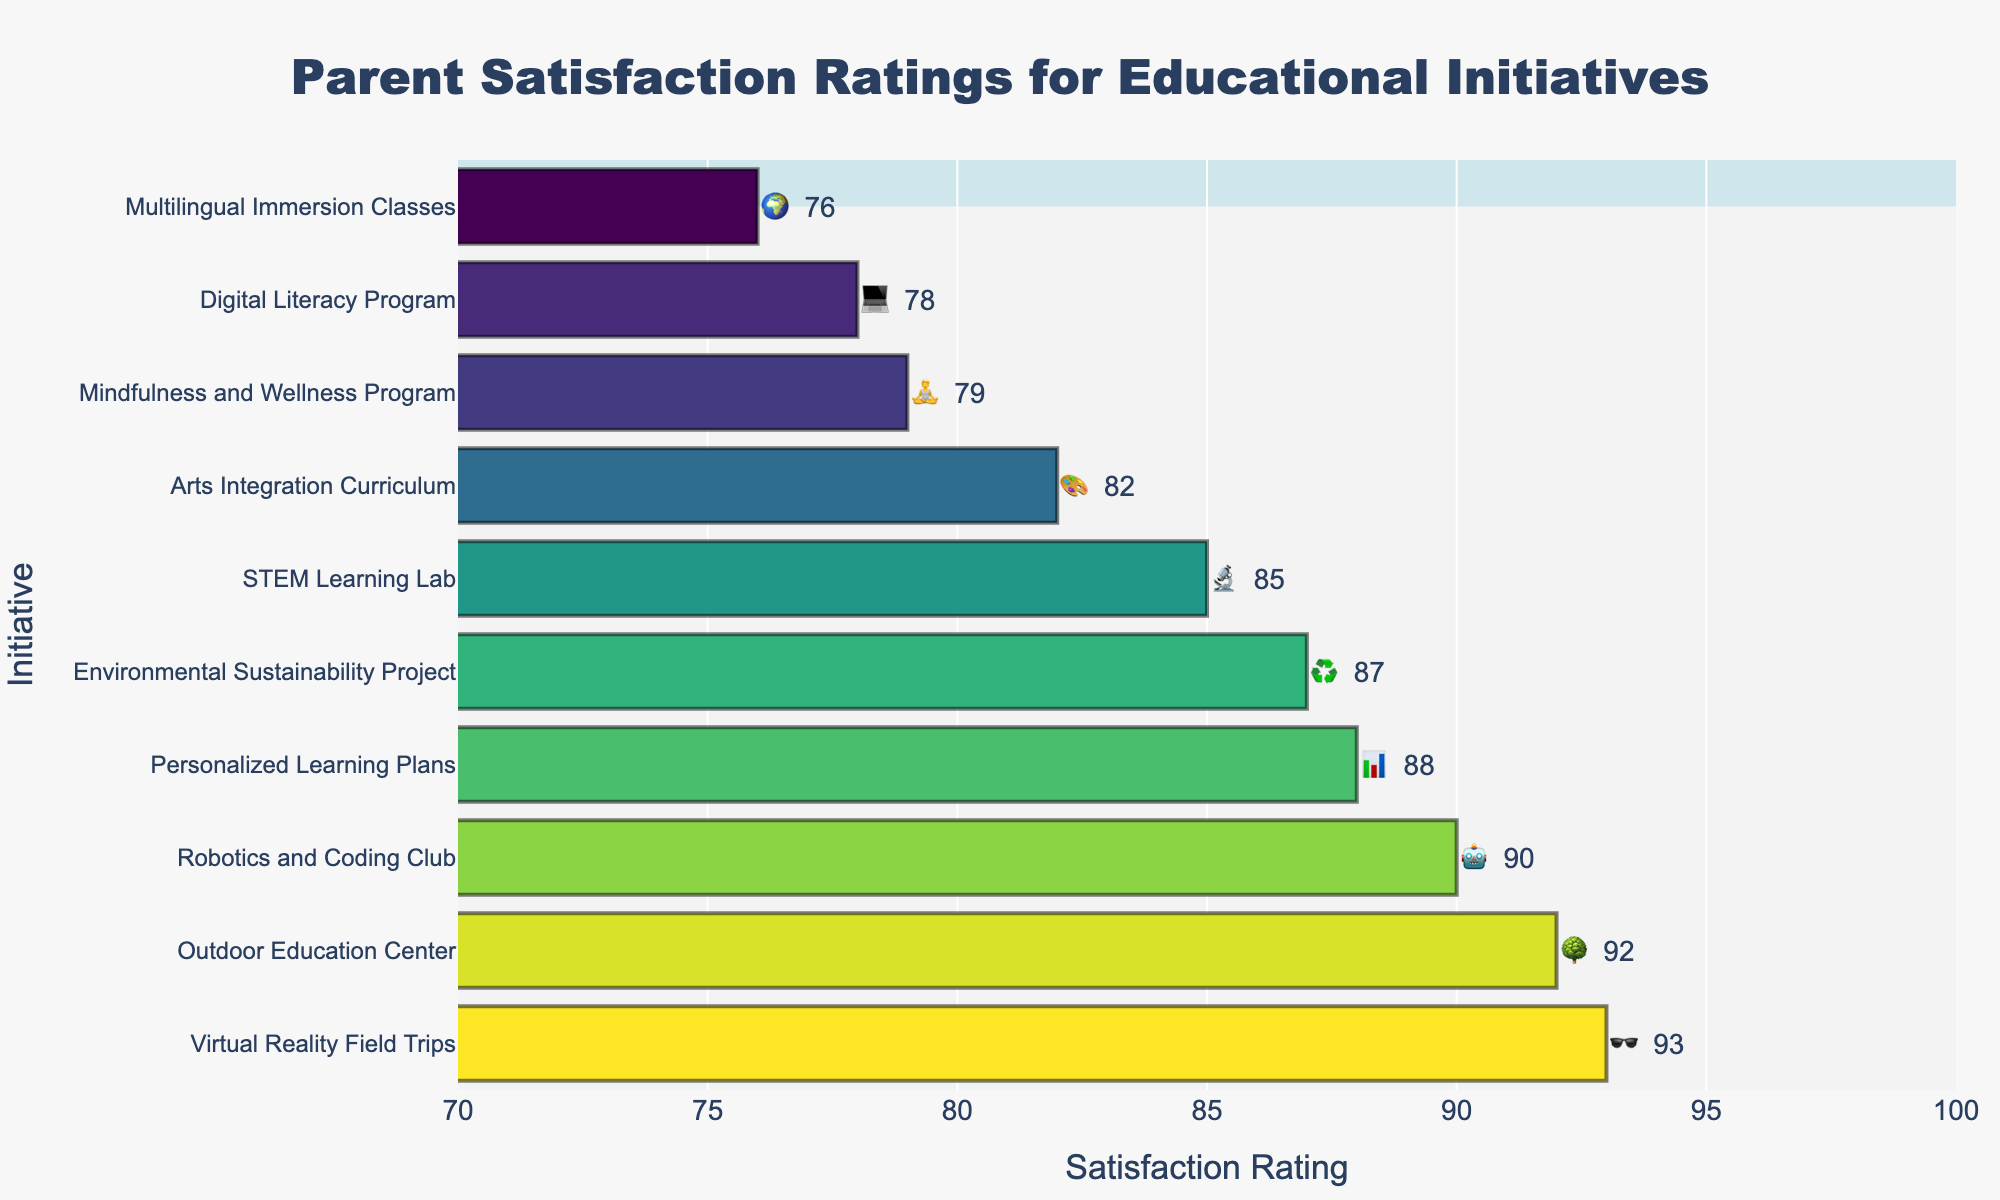What's the highest parent satisfaction rating among the initiatives? The Outdoor Education Center has a rating of 92, which is the highest among all initiatives.
Answer: 92 Which initiative has the lowest parent satisfaction rating? The Multilingual Immersion Classes have the lowest parent satisfaction rating with a score of 76.
Answer: The Multilingual Immersion Classes What is the satisfaction rating for the Virtual Reality Field Trips initiative? The Virtual Reality Field Trips initiative has a satisfaction rating of 93 according to the figure.
Answer: 93 How many initiatives have a satisfaction rating above 80? To find this, count the initiatives listed in the figure with ratings over 80. These initiatives are STEM Learning Lab, Outdoor Education Center, Personalized Learning Plans, Arts Integration Curriculum, Robotics and Coding Club, Environmental Sustainability Project, and Virtual Reality Field Trips. There are 7 such initiatives.
Answer: 7 Which initiative is represented by the emoji 🧘? The Mindfulness and Wellness Program is represented by the emoji 🧘 in the figure.
Answer: The Mindfulness and Wellness Program What is the difference in satisfaction ratings between the highest and lowest rated initiatives? The highest-rated initiative is the Virtual Reality Field Trips with a rating of 93, and the lowest rated is the Multilingual Immersion Classes with a rating of 76. The difference is 93 - 76 = 17.
Answer: 17 Between the Digital Literacy Program and the Arts Integration Curriculum, which has a higher satisfaction rating? The Arts Integration Curriculum has a satisfaction rating of 82, while the Digital Literacy Program has a rating of 78. Therefore, the Arts Integration Curriculum has a higher rating.
Answer: The Arts Integration Curriculum What percentage of initiatives have a satisfaction rating of 85 or higher? First, count the total number of initiatives, which is 10. Then count the initiatives with ratings of 85 or higher: STEM Learning Lab, Outdoor Education Center, Personalized Learning Plans, Robotics and Coding Club, Environmental Sustainability Project, and Virtual Reality Field Trips; there are 6. The percentage is (6/10)*100 = 60%.
Answer: 60% What is the combined satisfaction rating of the initiatives represented by the emojis 🌳, ♻️, and 🧘? The initiatives with the emojis 🌳 (Outdoor Education Center), ♻️ (Environmental Sustainability Project), and 🧘 (Mindfulness and Wellness Program) have ratings of 92, 87, and 79 respectively. Summing these gives 92 + 87 + 79 = 258.
Answer: 258 